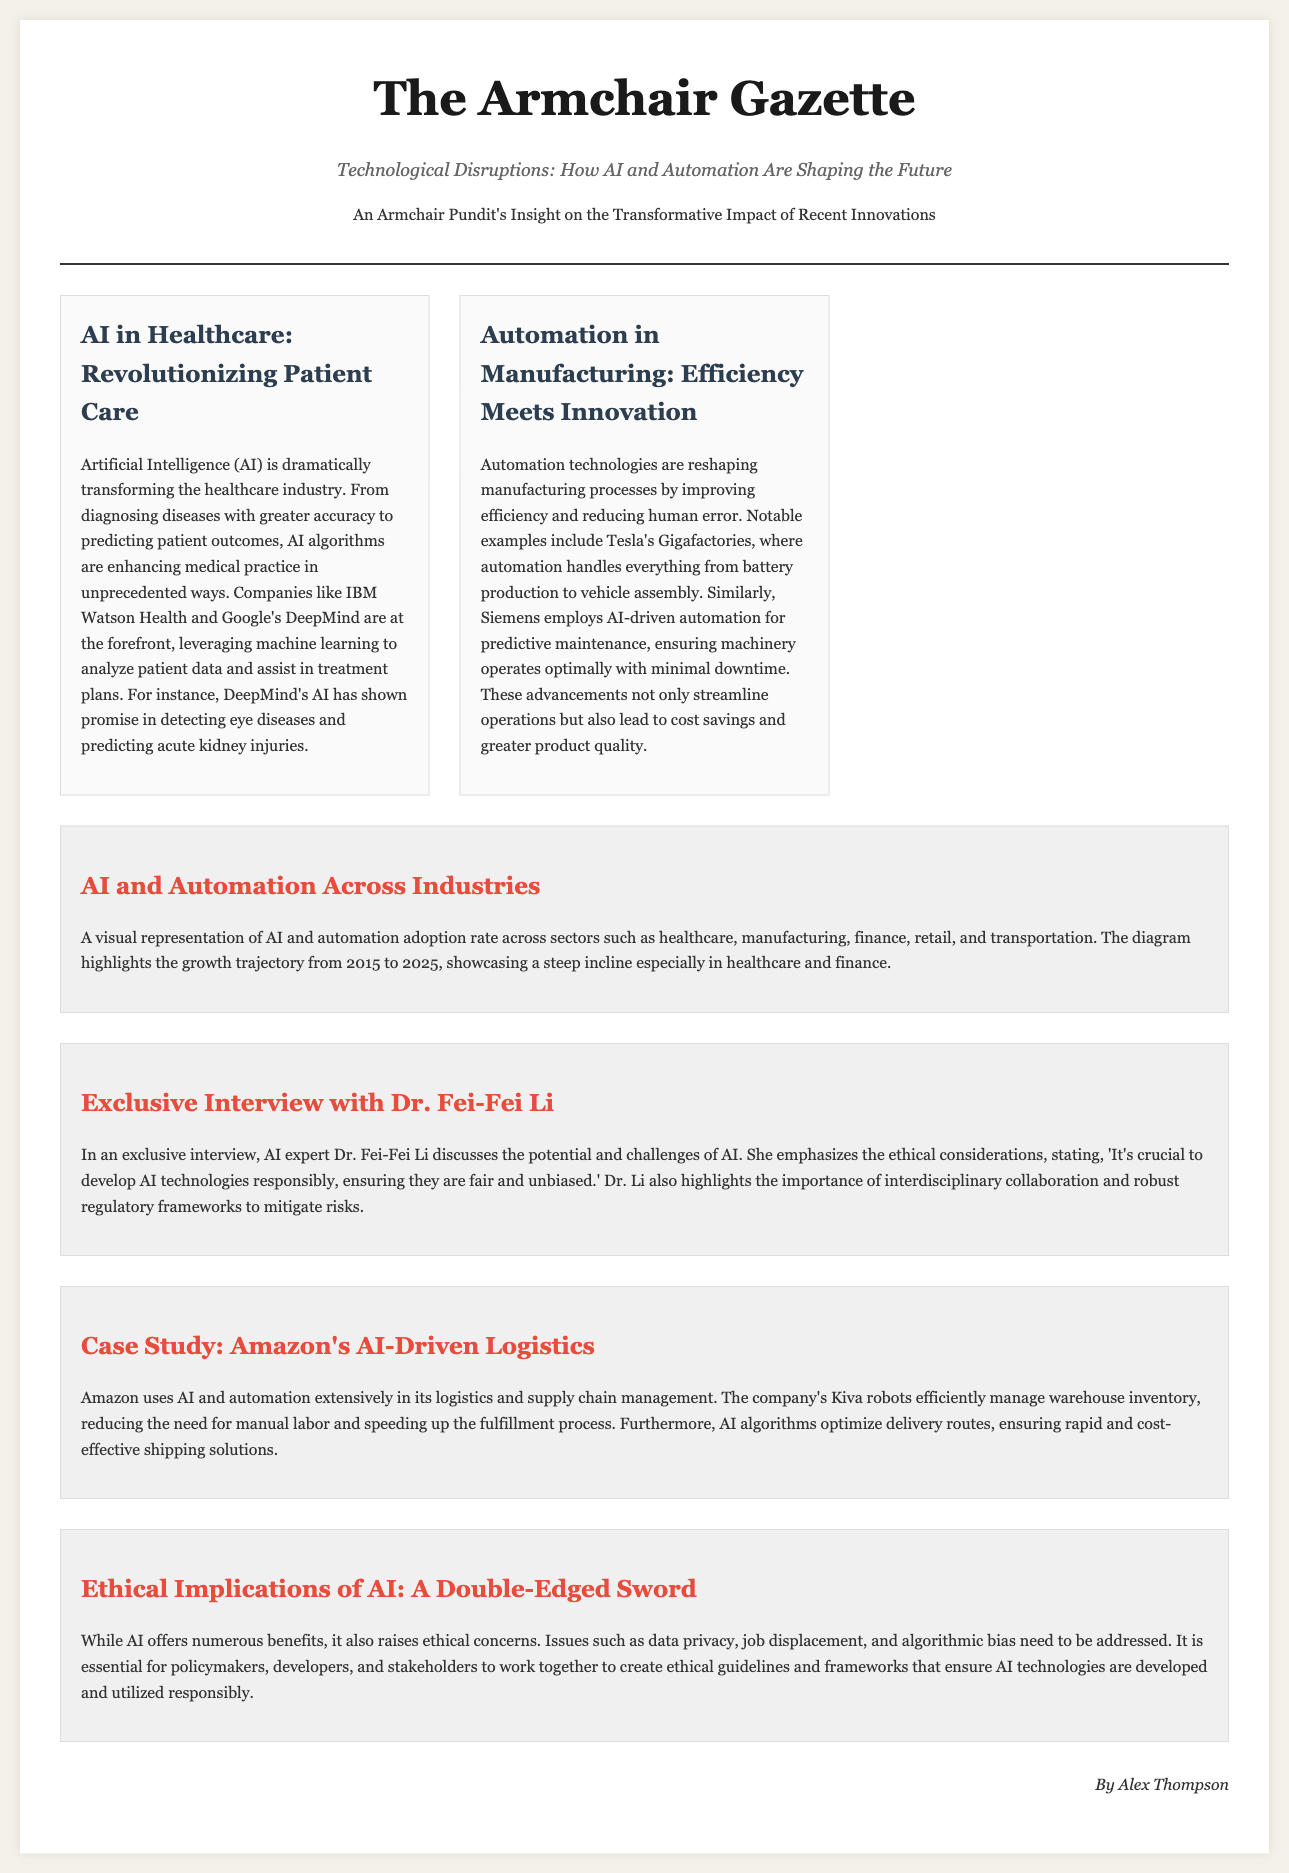What is the title of the article? The document contains a title that summarizes its main focus on technological disruptions, specifically AI and automation.
Answer: Technological Disruptions: How AI and Automation Are Shaping the Future Who is the author of the article? The author of the article is credited at the end of the document.
Answer: Alex Thompson What industry is highlighted in the case study? The document includes a specific case study on a company that utilizes AI technology significantly in its operations.
Answer: Logistics Which company is mentioned in the automation manufacturing example? The document cites a specific company known for its innovative manufacturing processes through automation.
Answer: Tesla What key ethical consideration is emphasized by Dr. Fei-Fei Li? The exclusive interview discusses the need for responsible development of technologies.
Answer: Fairness What year range does the diagram cover? The diagram visually represents the adoption rate across different sectors from one specific year to another.
Answer: 2015 to 2025 Which AI technology is used by Amazon for warehouse management? The document mentions a type of robot specifically used by Amazon to enhance logistics efficiency.
Answer: Kiva robots What is one of the benefits of AI mentioned? The article highlights a specific advantage of using AI technologies within industries.
Answer: Efficiency 